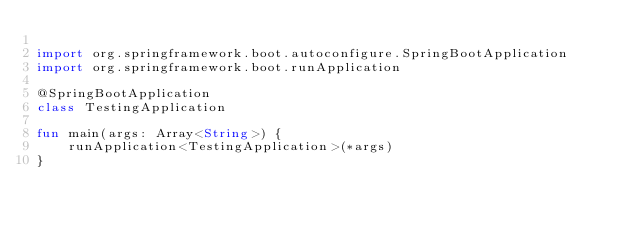Convert code to text. <code><loc_0><loc_0><loc_500><loc_500><_Kotlin_>
import org.springframework.boot.autoconfigure.SpringBootApplication
import org.springframework.boot.runApplication

@SpringBootApplication
class TestingApplication

fun main(args: Array<String>) {
	runApplication<TestingApplication>(*args)
}
</code> 